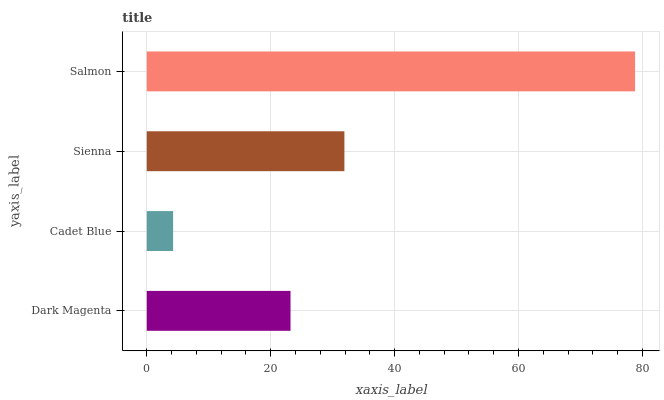Is Cadet Blue the minimum?
Answer yes or no. Yes. Is Salmon the maximum?
Answer yes or no. Yes. Is Sienna the minimum?
Answer yes or no. No. Is Sienna the maximum?
Answer yes or no. No. Is Sienna greater than Cadet Blue?
Answer yes or no. Yes. Is Cadet Blue less than Sienna?
Answer yes or no. Yes. Is Cadet Blue greater than Sienna?
Answer yes or no. No. Is Sienna less than Cadet Blue?
Answer yes or no. No. Is Sienna the high median?
Answer yes or no. Yes. Is Dark Magenta the low median?
Answer yes or no. Yes. Is Salmon the high median?
Answer yes or no. No. Is Sienna the low median?
Answer yes or no. No. 